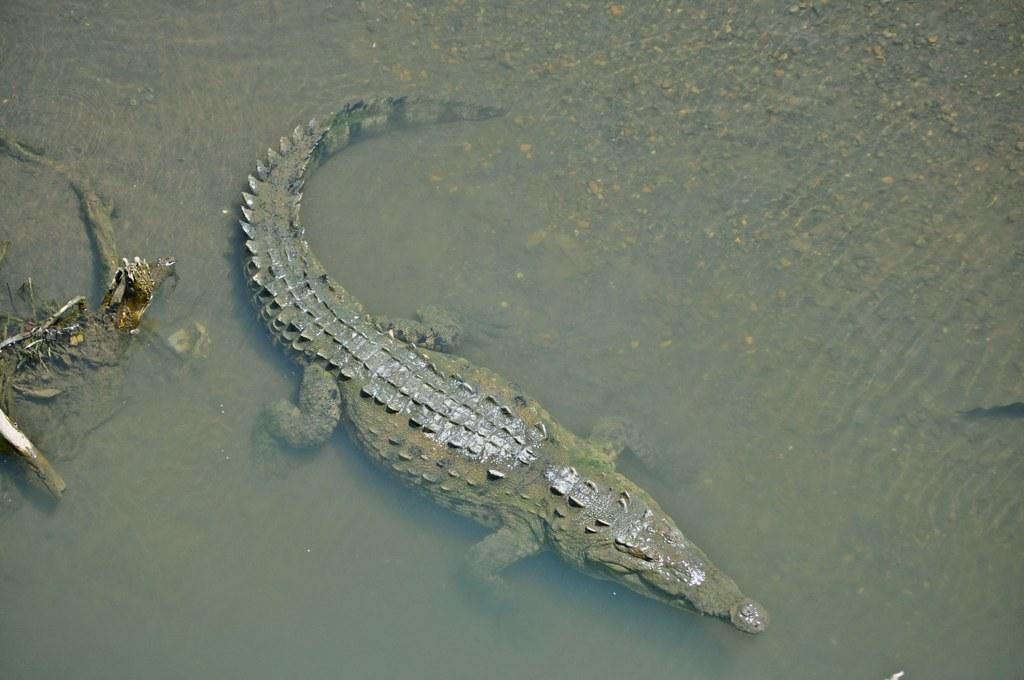What animal is present in the image? There is a crocodile in the image. Where is the crocodile located? The crocodile is in the water. What type of potato is being served in the library in the image? There is no potato or library present in the image; it features a crocodile in the water. What kind of performance is happening on the stage in the image? There is no stage or performance present in the image; it features a crocodile in the water. 